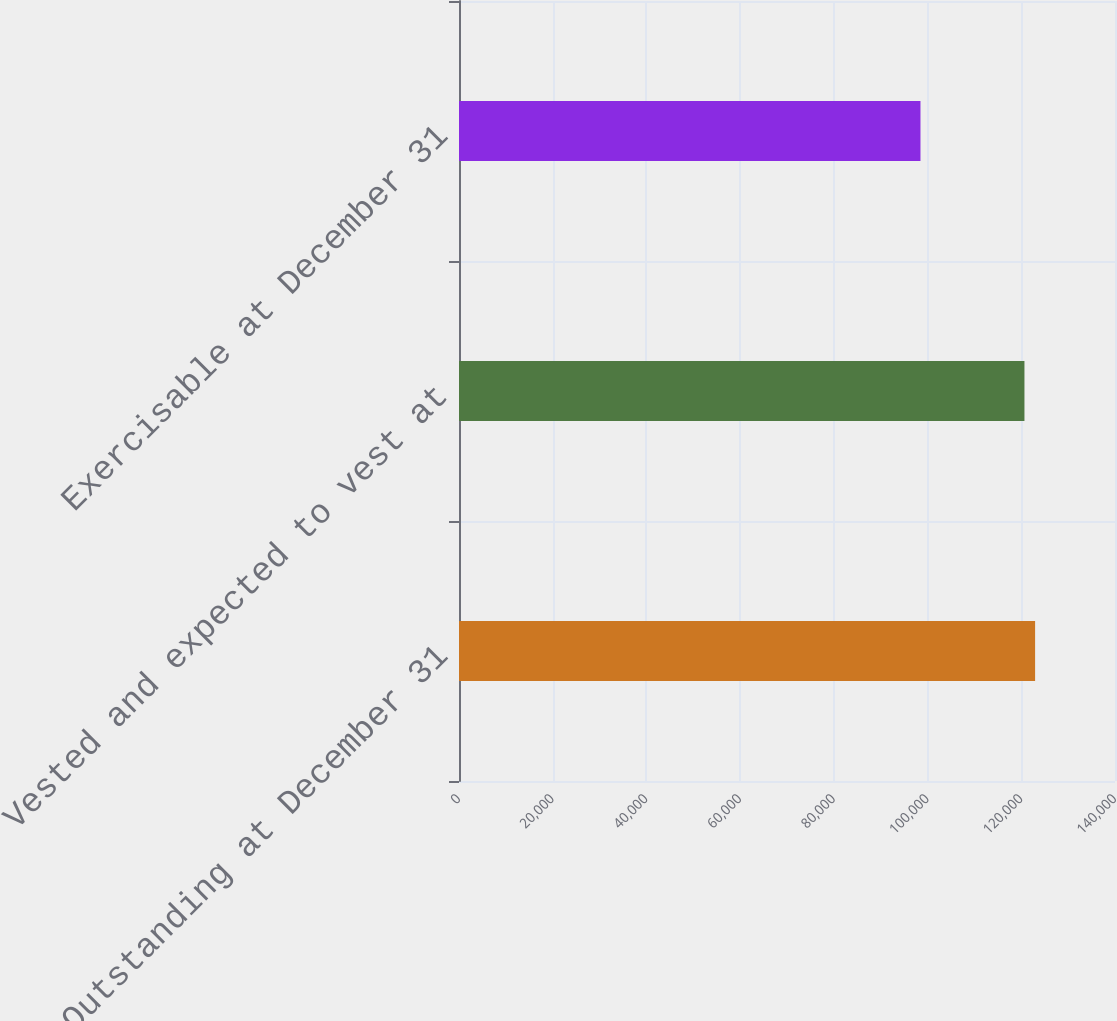Convert chart to OTSL. <chart><loc_0><loc_0><loc_500><loc_500><bar_chart><fcel>Outstanding at December 31<fcel>Vested and expected to vest at<fcel>Exercisable at December 31<nl><fcel>122947<fcel>120676<fcel>98485<nl></chart> 